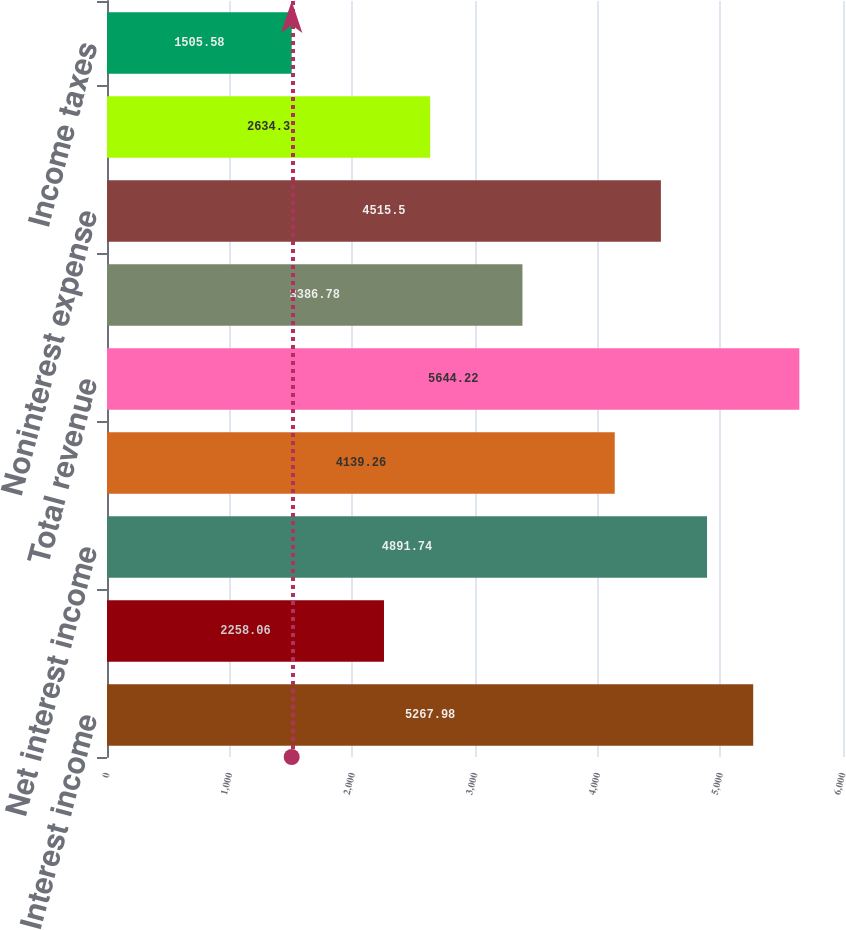Convert chart to OTSL. <chart><loc_0><loc_0><loc_500><loc_500><bar_chart><fcel>Interest income<fcel>Interest expense<fcel>Net interest income<fcel>Noninterest income (a)<fcel>Total revenue<fcel>Provision for credit losses<fcel>Noninterest expense<fcel>Income from continuing<fcel>Income taxes<nl><fcel>5267.98<fcel>2258.06<fcel>4891.74<fcel>4139.26<fcel>5644.22<fcel>3386.78<fcel>4515.5<fcel>2634.3<fcel>1505.58<nl></chart> 